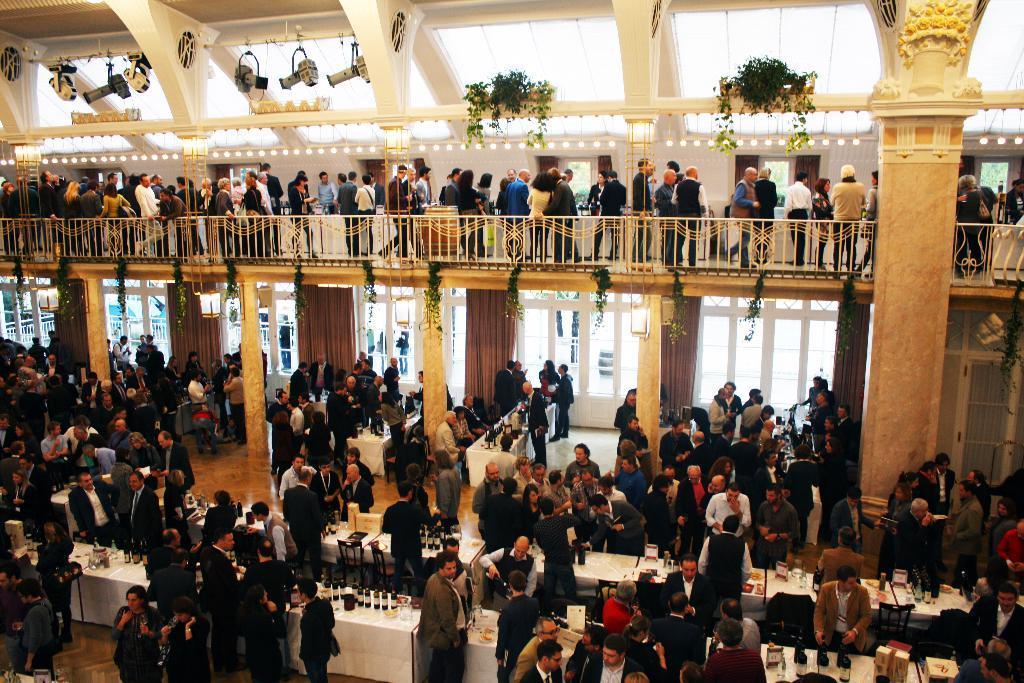Can you describe this image briefly? In this picture we can see some people are standing on the path and on the path there are tables and on the tables there are bottles, glasses and some objects. Behind the people there are pillars and some decorative plants. At the top there are some objects. 